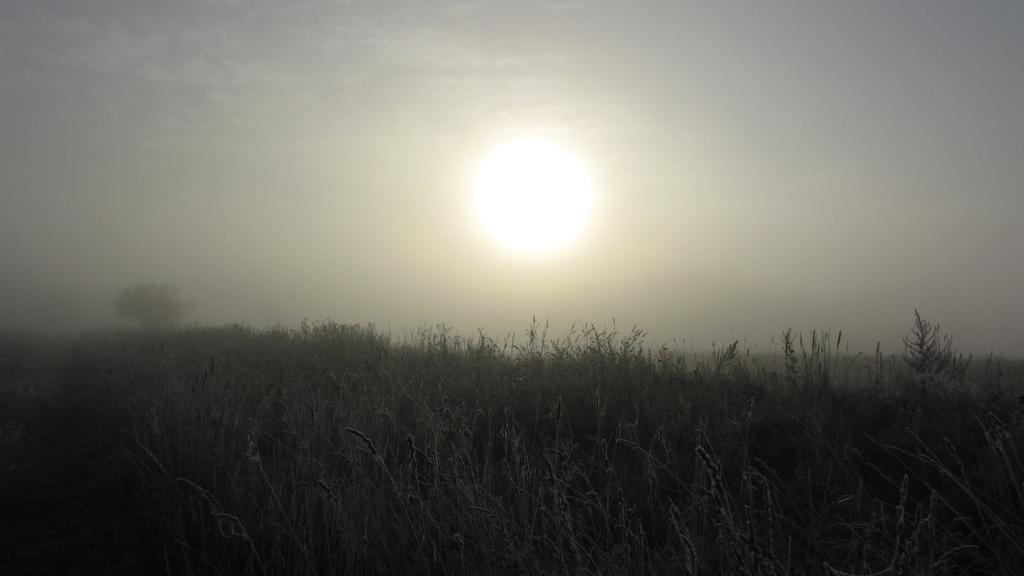What type of living organisms can be seen in the image? Plants and a tree are visible in the image. What is visible in the background of the image? The sky is visible in the background of the image. Can the sun be seen in the image? Yes, the sun is observable in the sky. What type of yoke can be seen in the image? There is no yoke present in the image. How many boys are visible in the image? There are no boys visible in the image. 